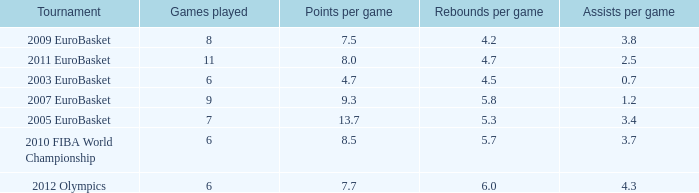How many assists per game in the tournament 2010 fiba world championship? 3.7. 